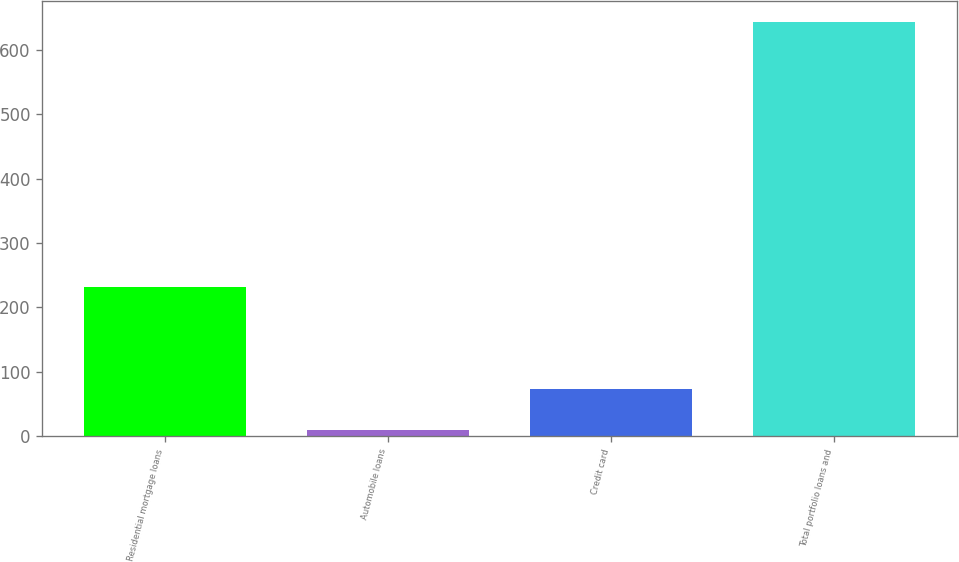Convert chart. <chart><loc_0><loc_0><loc_500><loc_500><bar_chart><fcel>Residential mortgage loans<fcel>Automobile loans<fcel>Credit card<fcel>Total portfolio loans and<nl><fcel>231<fcel>10<fcel>73.3<fcel>643<nl></chart> 